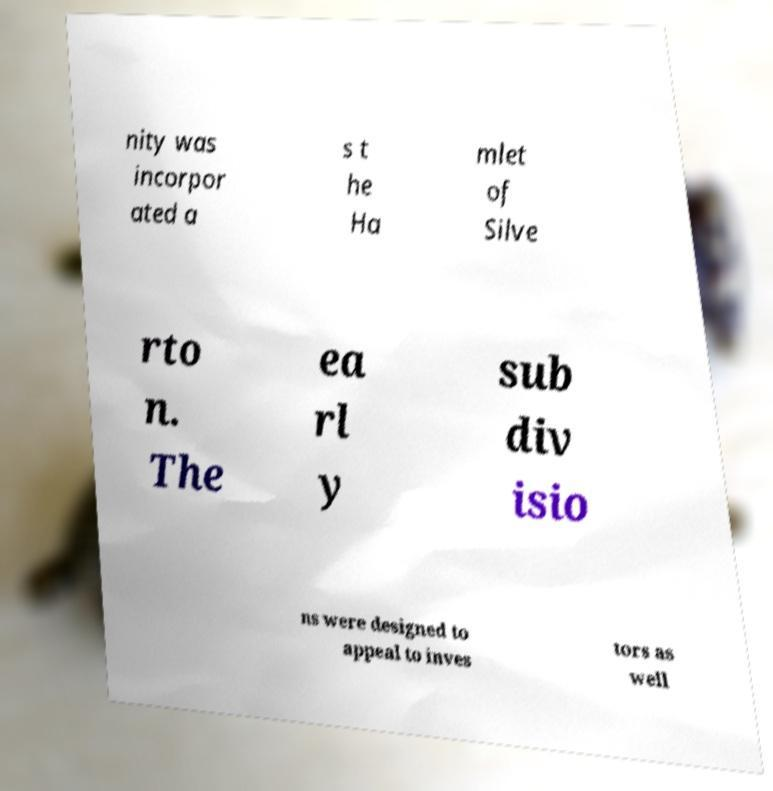There's text embedded in this image that I need extracted. Can you transcribe it verbatim? nity was incorpor ated a s t he Ha mlet of Silve rto n. The ea rl y sub div isio ns were designed to appeal to inves tors as well 